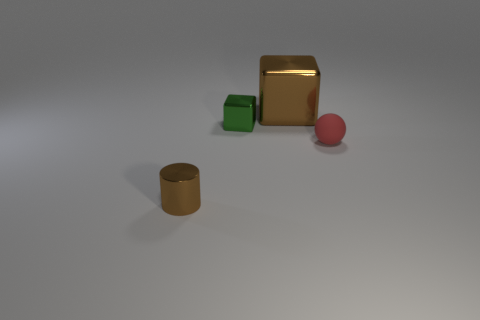What number of small balls are left of the tiny brown cylinder?
Your response must be concise. 0. How big is the brown shiny cylinder?
Provide a succinct answer. Small. What color is the rubber ball that is the same size as the brown cylinder?
Offer a terse response. Red. Is there a cube that has the same color as the tiny metal cylinder?
Make the answer very short. Yes. What material is the small red object?
Offer a terse response. Rubber. How many big cyan rubber blocks are there?
Keep it short and to the point. 0. There is a large metal cube that is right of the green shiny thing; does it have the same color as the small object in front of the red matte object?
Provide a succinct answer. Yes. The shiny cylinder that is the same color as the large metallic object is what size?
Your answer should be very brief. Small. How many other things are the same size as the brown metallic cube?
Offer a very short reply. 0. There is a cube that is right of the tiny metal cube; what is its color?
Ensure brevity in your answer.  Brown. 